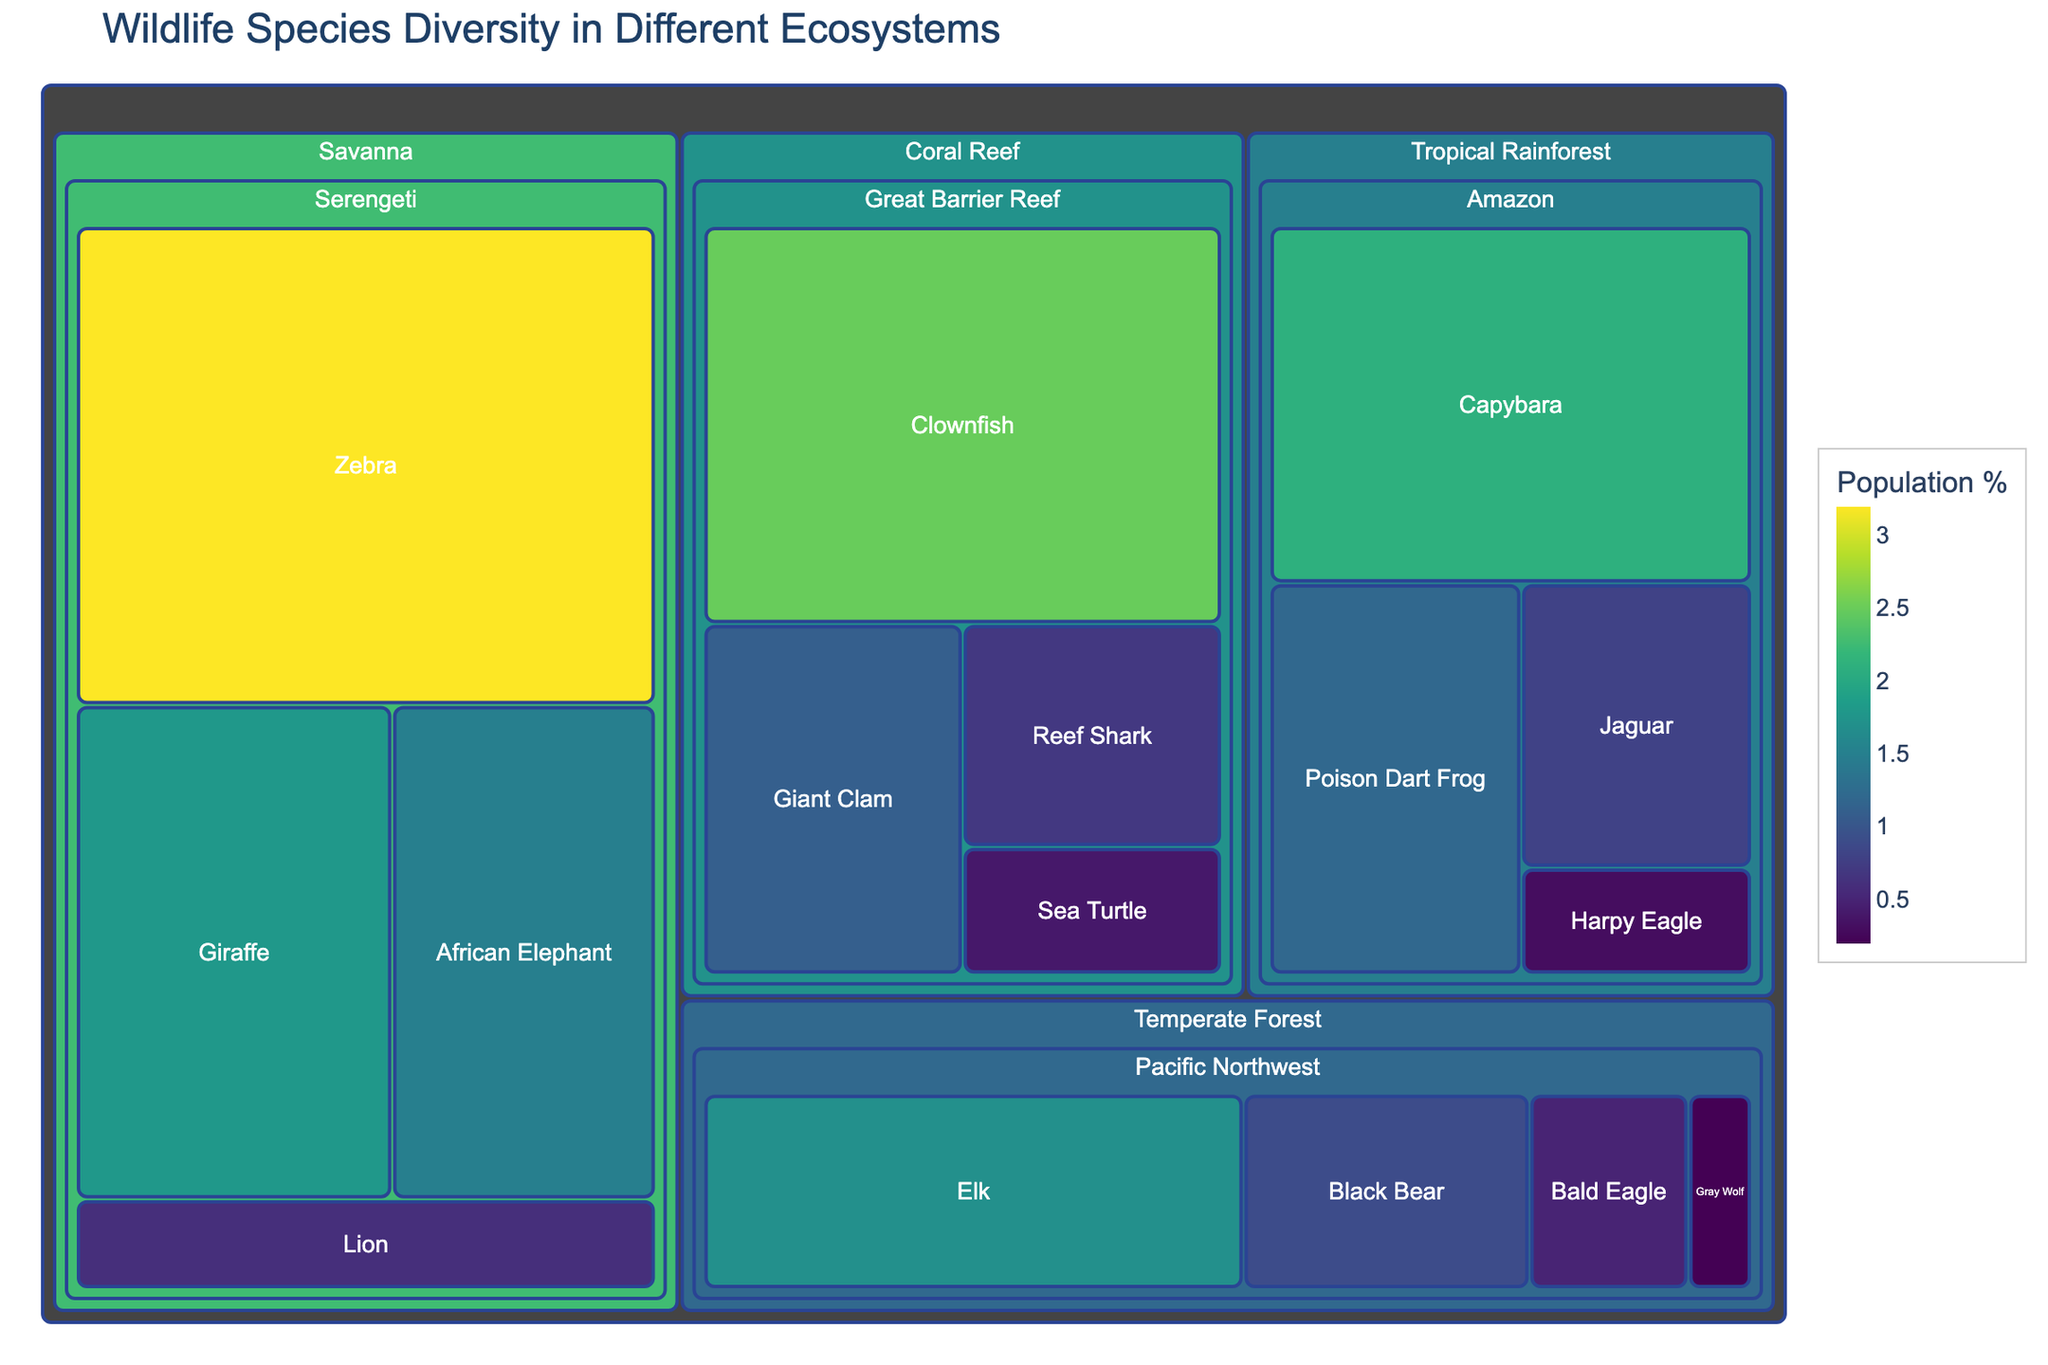What's the title of the treemap? The title is located at the top of the figure and it's designed to provide a succinct summary of the visualized data. It reads: "Wildlife Species Diversity in Different Ecosystems".
Answer: Wildlife Species Diversity in Different Ecosystems Which species in the Amazon rainforest has the highest population percentage? By looking at the sections in the 'Tropical Rainforest > Amazon' part of the treemap, you can see each labeled species and their corresponding population percentages. The Capybara has the highest percentage.
Answer: Capybara What is the combined population percentage of all species in the Serengeti? Sum the population percentages of African Elephant (1.5), Lion (0.6), Giraffe (1.8), and Zebra (3.2). So, the combined percentage is 1.5 + 0.6 + 1.8 + 3.2 = 7.1%.
Answer: 7.1% Which habitat among the four has the most diverse range of species based on the number of different species shown? Look at the number of sections within each habitat block: Amazon, Serengeti, Great Barrier Reef, and Pacific Northwest. The Serengeti has the highest number of different species with four.
Answer: Serengeti How does the population percentage of the Harpy Eagle in the Amazon compare to that of the Bald Eagle in the Pacific Northwest? Compare the population percentages directly from the treemap. The Harpy Eagle has 0.3% while the Bald Eagle has 0.5%.
Answer: Harpy Eagle is less than Bald Eagle Which species in the Coral Reef has the smallest population percentage? Among Clownfish, Sea Turtle, Reef Shark, and Giant Clam, the Sea Turtle has the smallest population percentage with 0.4%.
Answer: Sea Turtle What is the average population percentage of species in the Pacific Northwest? Sum the population percentages of Gray Wolf (0.2), Black Bear (0.9), Bald Eagle (0.5), and Elk (1.7), then divide by the number of species: (0.2 + 0.9 + 0.5 + 1.7) / 4 = 3.3 / 4 = 0.825%.
Answer: 0.825% Which ecosystem has the highest total population percentage? Sum the population percentages of all species within each ecosystem: Tropical Rainforest (4.4%), Savanna (7.1%), Coral Reef (4.7%), and Temperate Forest (3.3%). The Savanna has the highest total with 7.1%.
Answer: Savanna 